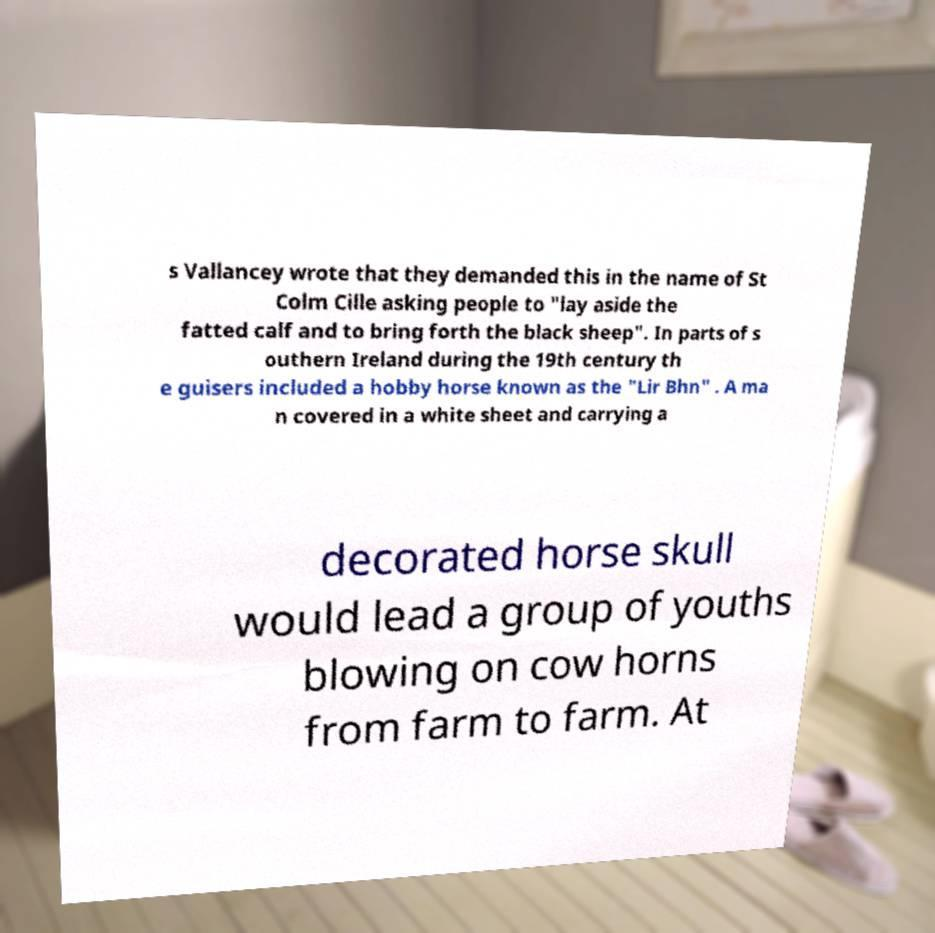What messages or text are displayed in this image? I need them in a readable, typed format. s Vallancey wrote that they demanded this in the name of St Colm Cille asking people to "lay aside the fatted calf and to bring forth the black sheep". In parts of s outhern Ireland during the 19th century th e guisers included a hobby horse known as the "Lir Bhn" . A ma n covered in a white sheet and carrying a decorated horse skull would lead a group of youths blowing on cow horns from farm to farm. At 